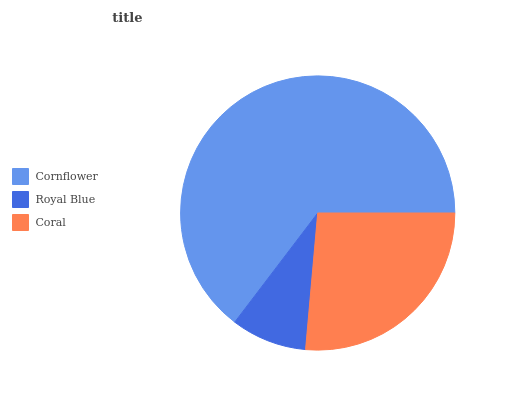Is Royal Blue the minimum?
Answer yes or no. Yes. Is Cornflower the maximum?
Answer yes or no. Yes. Is Coral the minimum?
Answer yes or no. No. Is Coral the maximum?
Answer yes or no. No. Is Coral greater than Royal Blue?
Answer yes or no. Yes. Is Royal Blue less than Coral?
Answer yes or no. Yes. Is Royal Blue greater than Coral?
Answer yes or no. No. Is Coral less than Royal Blue?
Answer yes or no. No. Is Coral the high median?
Answer yes or no. Yes. Is Coral the low median?
Answer yes or no. Yes. Is Royal Blue the high median?
Answer yes or no. No. Is Royal Blue the low median?
Answer yes or no. No. 